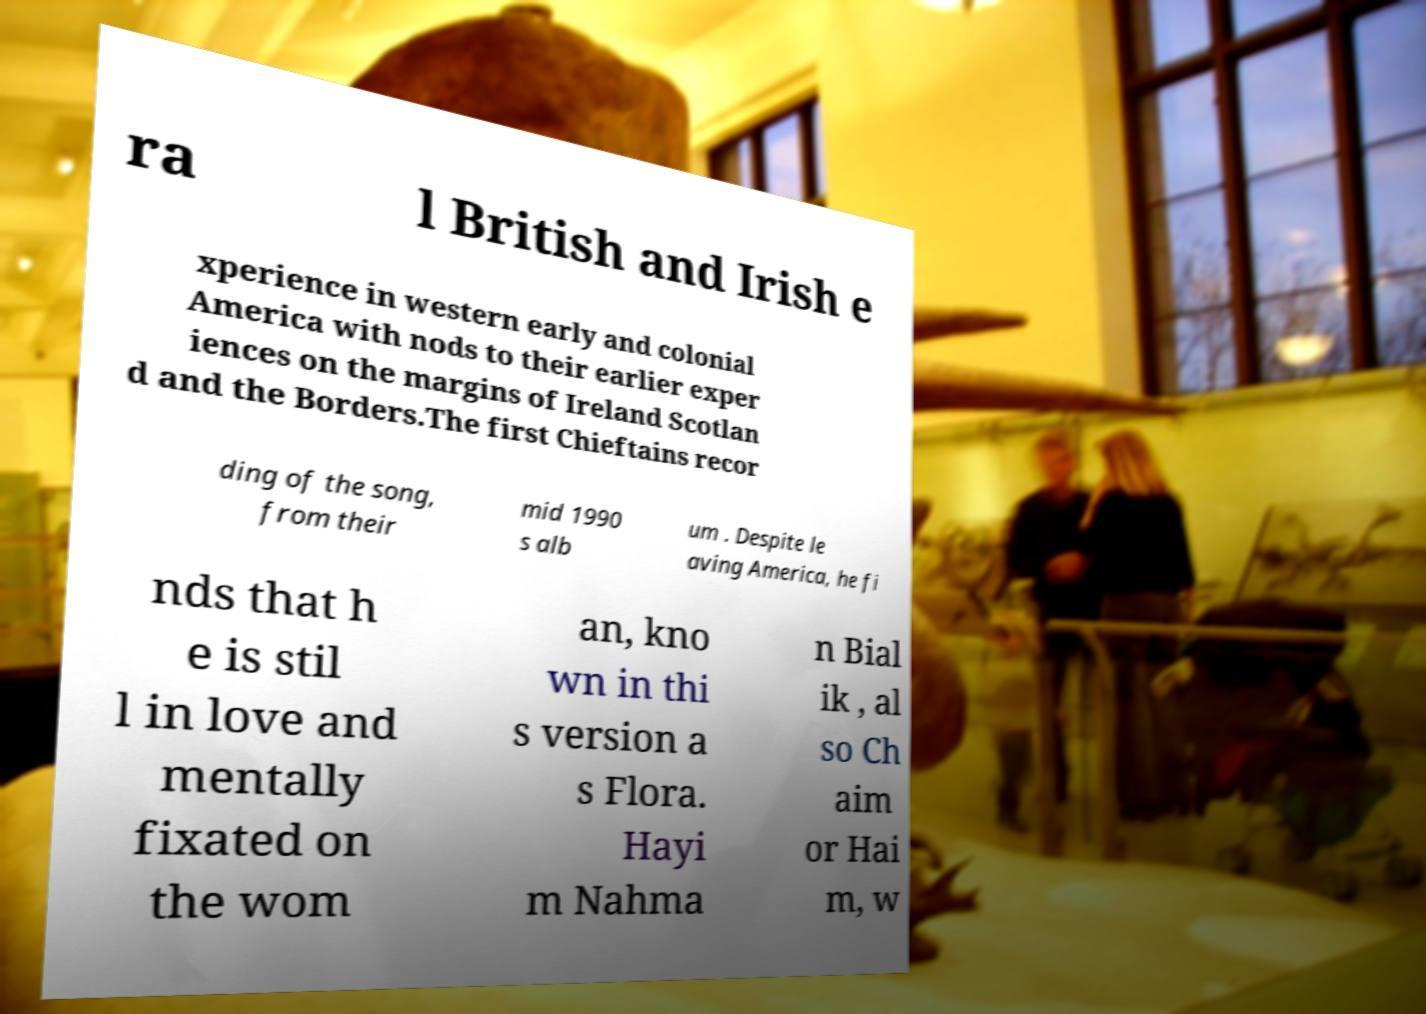Can you read and provide the text displayed in the image?This photo seems to have some interesting text. Can you extract and type it out for me? ra l British and Irish e xperience in western early and colonial America with nods to their earlier exper iences on the margins of Ireland Scotlan d and the Borders.The first Chieftains recor ding of the song, from their mid 1990 s alb um . Despite le aving America, he fi nds that h e is stil l in love and mentally fixated on the wom an, kno wn in thi s version a s Flora. Hayi m Nahma n Bial ik , al so Ch aim or Hai m, w 